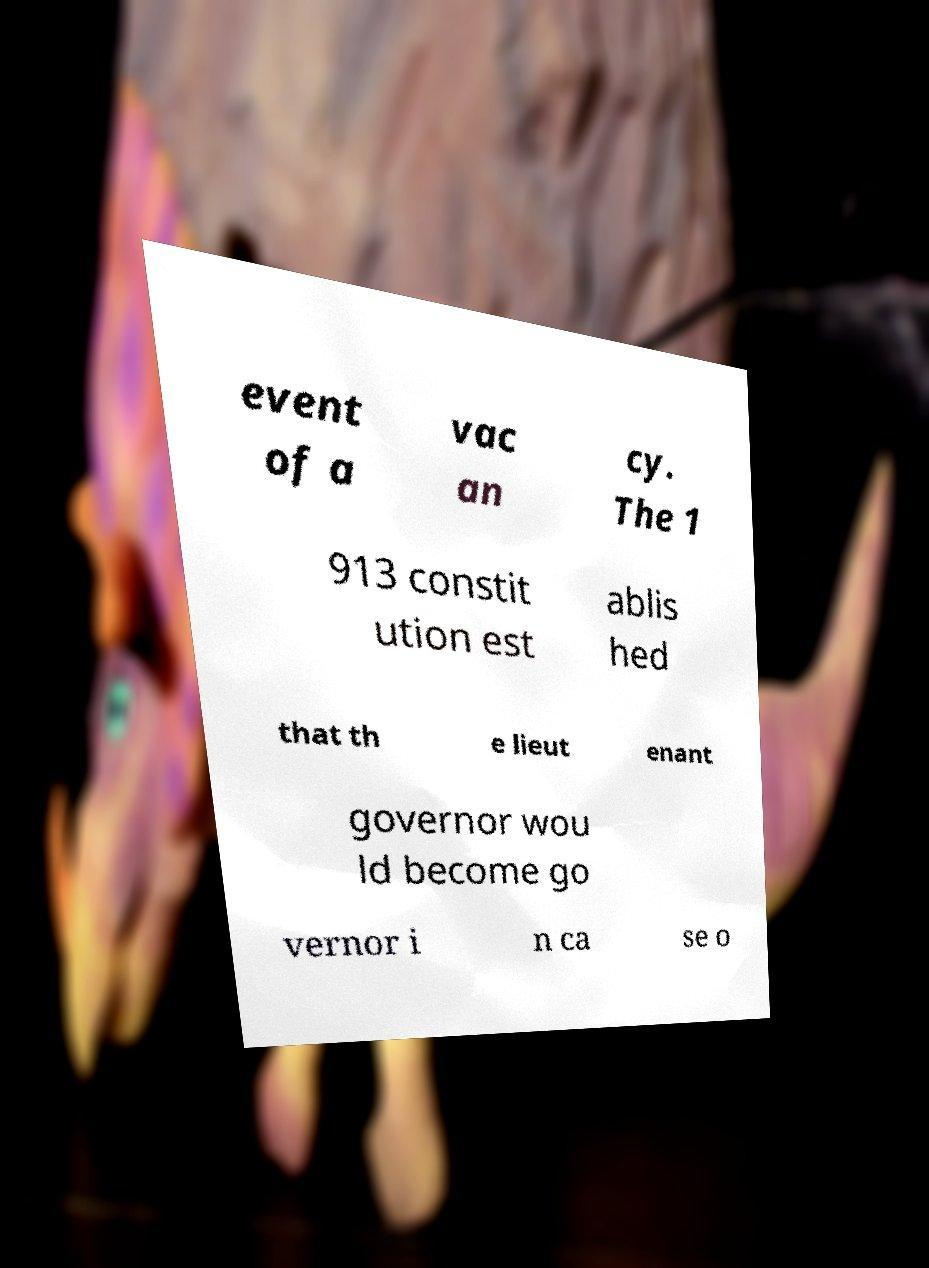For documentation purposes, I need the text within this image transcribed. Could you provide that? event of a vac an cy. The 1 913 constit ution est ablis hed that th e lieut enant governor wou ld become go vernor i n ca se o 